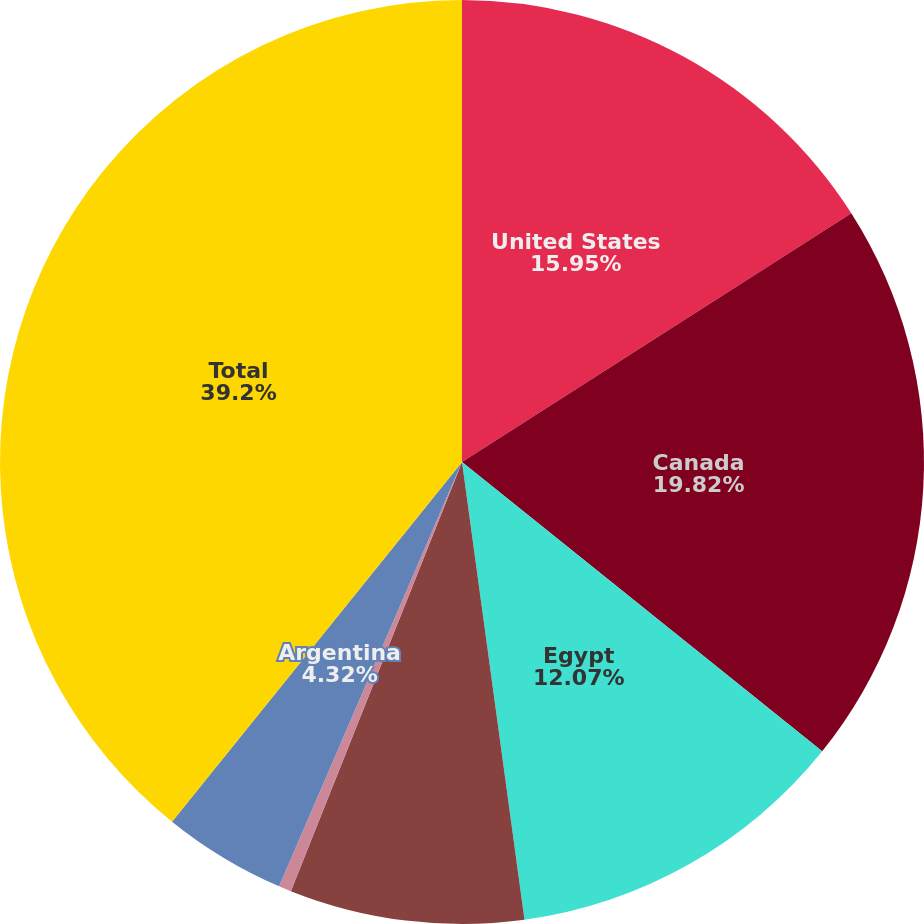Convert chart to OTSL. <chart><loc_0><loc_0><loc_500><loc_500><pie_chart><fcel>United States<fcel>Canada<fcel>Egypt<fcel>Australia<fcel>North Sea<fcel>Argentina<fcel>Total<nl><fcel>15.95%<fcel>19.82%<fcel>12.07%<fcel>8.2%<fcel>0.44%<fcel>4.32%<fcel>39.2%<nl></chart> 